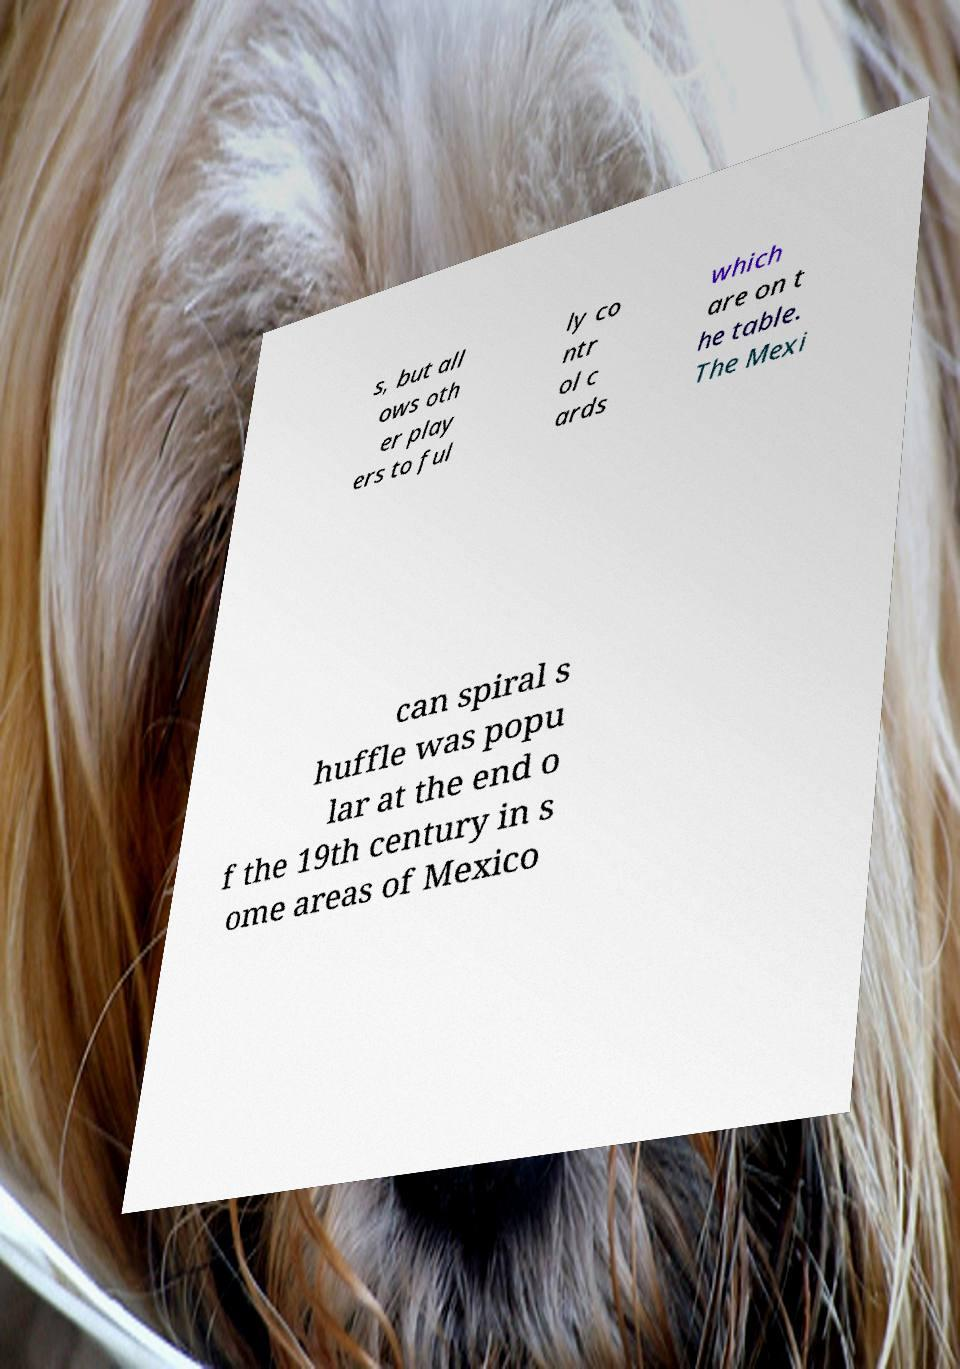Can you accurately transcribe the text from the provided image for me? s, but all ows oth er play ers to ful ly co ntr ol c ards which are on t he table. The Mexi can spiral s huffle was popu lar at the end o f the 19th century in s ome areas of Mexico 